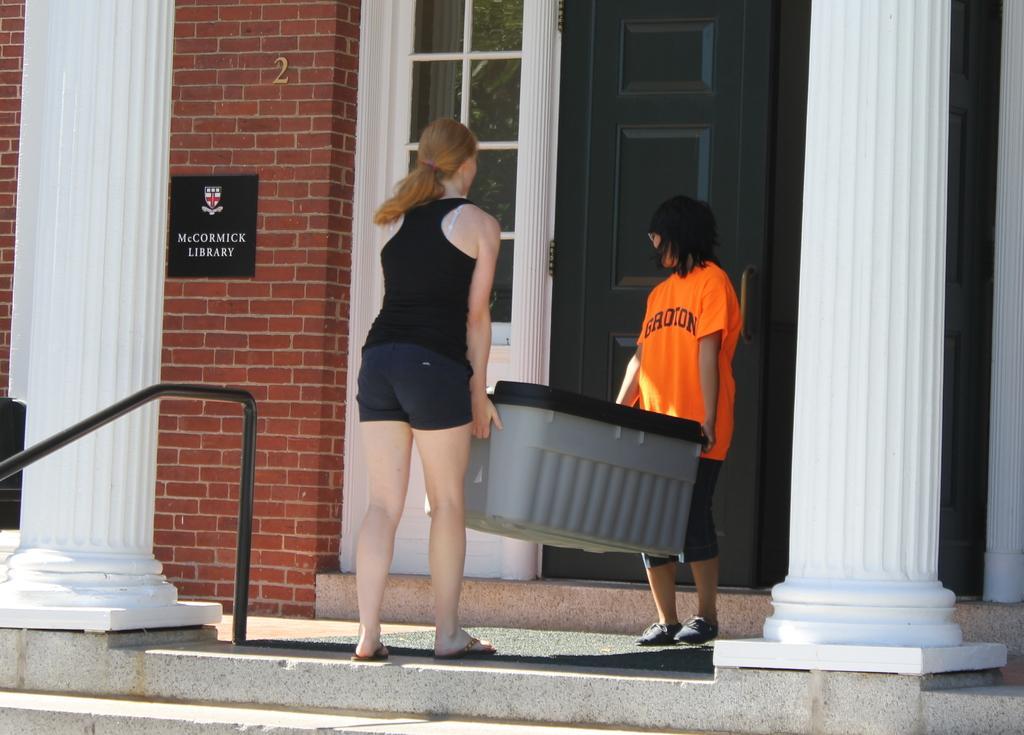In one or two sentences, can you explain what this image depicts? In this image there are two ladies holding a box their hands, on either side of the ladies there are too white pillars, in the background there is a door and a wall. 